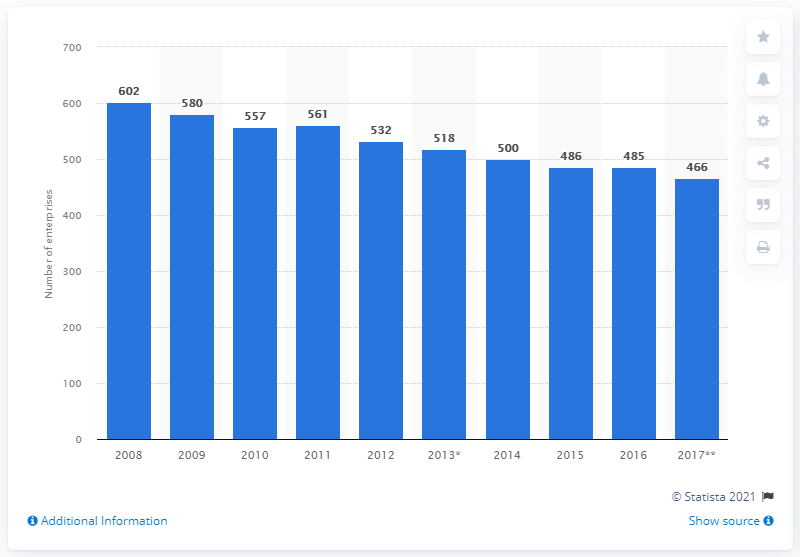Mention a couple of crucial points in this snapshot. In 2017, there were 466 enterprises operating in the plastics products industry in Finland. 